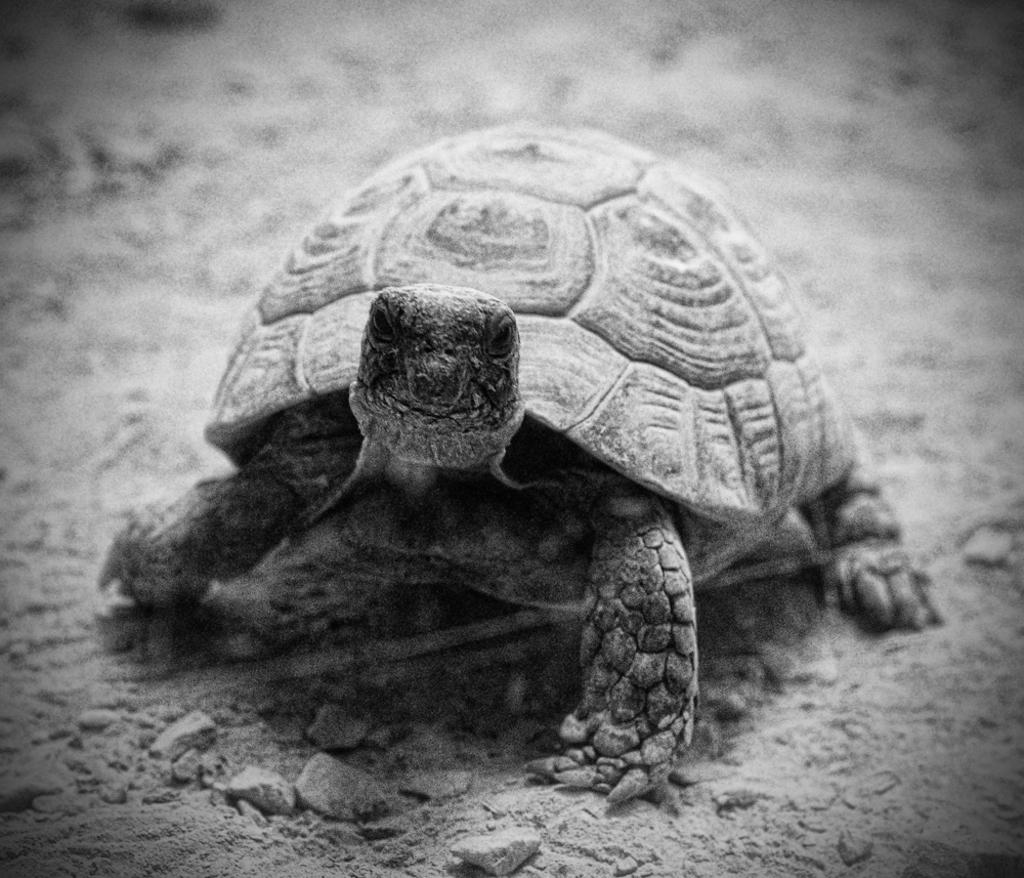What is the color scheme of the image? The image is black and white. What animal can be seen in the image? There is a turtle in the image. Can you describe the background of the image? The background of the image is blurred. How many clams are visible on the turtle's back in the image? There are no clams visible on the turtle's back in the image. Can you tell me how many friends the turtle has in the image? There are no friends visible in the image; it only features a turtle. 